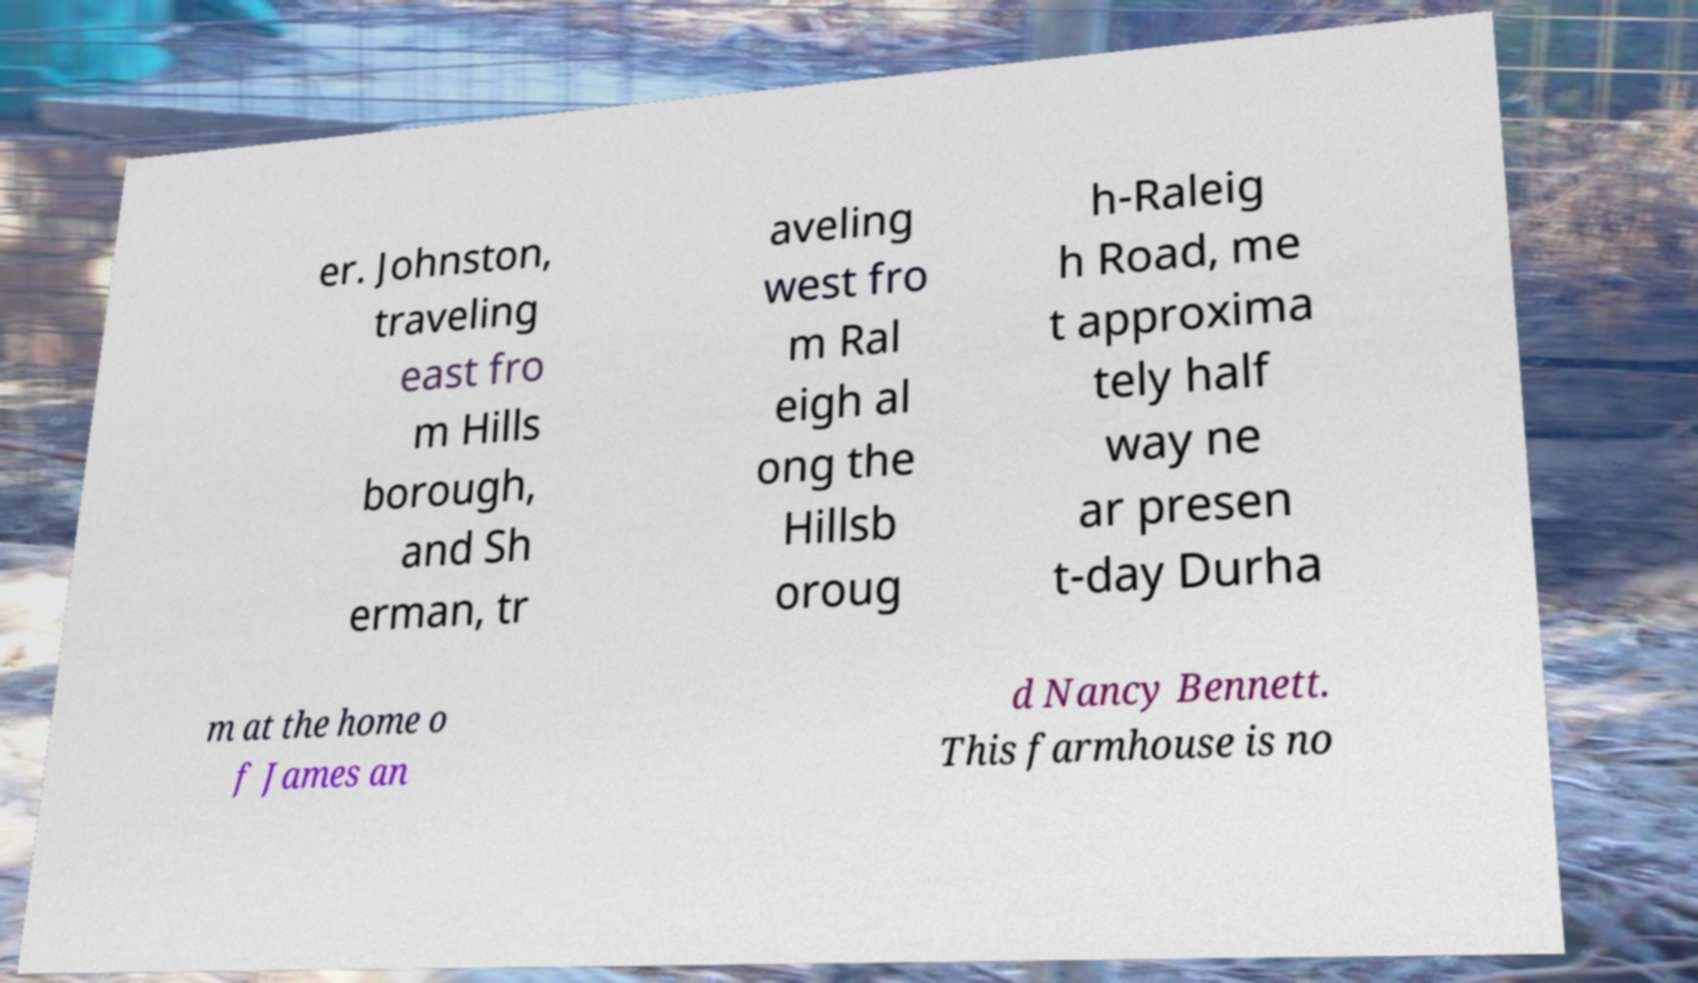There's text embedded in this image that I need extracted. Can you transcribe it verbatim? er. Johnston, traveling east fro m Hills borough, and Sh erman, tr aveling west fro m Ral eigh al ong the Hillsb oroug h-Raleig h Road, me t approxima tely half way ne ar presen t-day Durha m at the home o f James an d Nancy Bennett. This farmhouse is no 